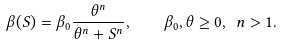Convert formula to latex. <formula><loc_0><loc_0><loc_500><loc_500>\beta ( S ) = \beta _ { 0 } \frac { \theta ^ { n } } { \theta ^ { n } + S ^ { n } } , \quad \beta _ { 0 } , \theta \geq 0 , \ n > 1 .</formula> 